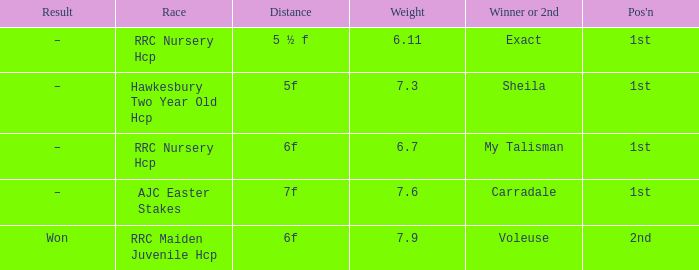What was the race when the winner of 2nd was Voleuse? RRC Maiden Juvenile Hcp. 